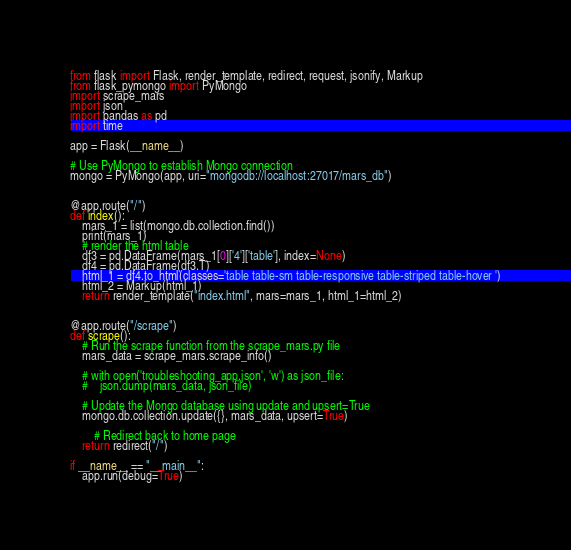<code> <loc_0><loc_0><loc_500><loc_500><_Python_>from flask import Flask, render_template, redirect, request, jsonify, Markup
from flask_pymongo import PyMongo
import scrape_mars
import json
import pandas as pd
import time

app = Flask(__name__)

# Use PyMongo to establish Mongo connection
mongo = PyMongo(app, uri="mongodb://localhost:27017/mars_db")


@app.route("/")
def index():
    mars_1 = list(mongo.db.collection.find())
    print(mars_1)
    # render the html table
    df3 = pd.DataFrame(mars_1[0]['4']['table'], index=None)
    df4 = pd.DataFrame(df3.T)
    html_1 = df4.to_html(classes='table table-sm table-responsive table-striped table-hover ')
    html_2 = Markup(html_1)
    return render_template("index.html", mars=mars_1, html_1=html_2)


@app.route("/scrape")
def scrape():
    # Run the scrape function from the scrape_mars.py file
    mars_data = scrape_mars.scrape_info()

    # with open('troubleshooting_app.json', 'w') as json_file:
    #    json.dump(mars_data, json_file)
    
    # Update the Mongo database using update and upsert=True
    mongo.db.collection.update({}, mars_data, upsert=True)

        # Redirect back to home page
    return redirect("/")

if __name__ == "__main__":
    app.run(debug=True)
</code> 